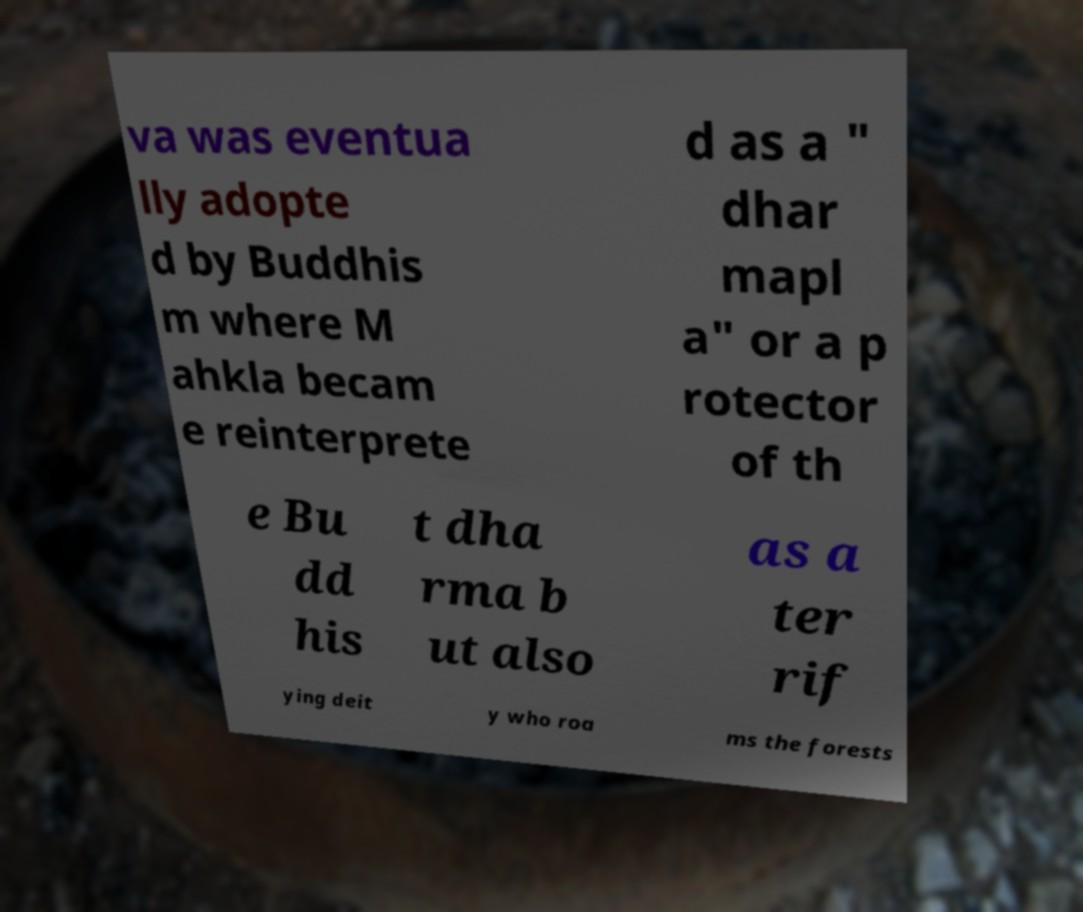Could you assist in decoding the text presented in this image and type it out clearly? va was eventua lly adopte d by Buddhis m where M ahkla becam e reinterprete d as a " dhar mapl a" or a p rotector of th e Bu dd his t dha rma b ut also as a ter rif ying deit y who roa ms the forests 